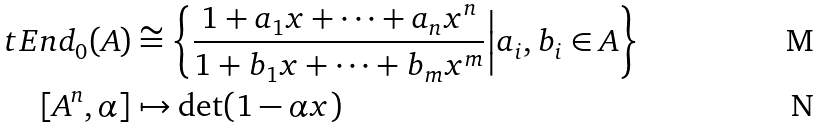Convert formula to latex. <formula><loc_0><loc_0><loc_500><loc_500>\ t E n d _ { 0 } ( A ) & \cong \left \{ \frac { 1 + a _ { 1 } x + \cdots + a _ { n } x ^ { n } } { 1 + b _ { 1 } x + \cdots + b _ { m } x ^ { m } } \Big { | } a _ { i } , b _ { i } \in A \right \} \\ [ A ^ { n } , \alpha ] & \mapsto \det ( 1 - \alpha x )</formula> 